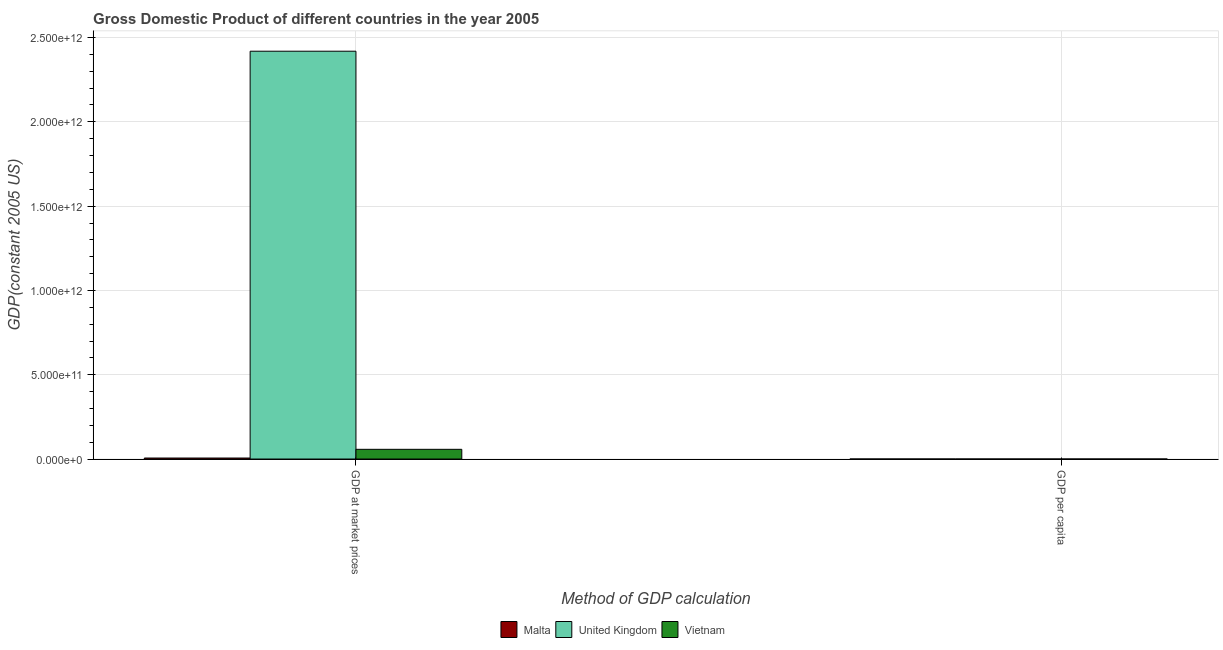Are the number of bars on each tick of the X-axis equal?
Provide a succinct answer. Yes. How many bars are there on the 2nd tick from the left?
Your response must be concise. 3. What is the label of the 1st group of bars from the left?
Ensure brevity in your answer.  GDP at market prices. What is the gdp per capita in Malta?
Your answer should be very brief. 1.48e+04. Across all countries, what is the maximum gdp per capita?
Make the answer very short. 4.00e+04. Across all countries, what is the minimum gdp at market prices?
Ensure brevity in your answer.  5.99e+09. In which country was the gdp per capita maximum?
Keep it short and to the point. United Kingdom. In which country was the gdp per capita minimum?
Offer a terse response. Vietnam. What is the total gdp per capita in the graph?
Provide a succinct answer. 5.56e+04. What is the difference between the gdp at market prices in Malta and that in Vietnam?
Your response must be concise. -5.16e+1. What is the difference between the gdp per capita in Vietnam and the gdp at market prices in Malta?
Ensure brevity in your answer.  -5.99e+09. What is the average gdp at market prices per country?
Provide a succinct answer. 8.28e+11. What is the difference between the gdp per capita and gdp at market prices in Malta?
Your answer should be compact. -5.99e+09. What is the ratio of the gdp at market prices in United Kingdom to that in Malta?
Ensure brevity in your answer.  403.79. What does the 1st bar from the left in GDP per capita represents?
Offer a terse response. Malta. What does the 3rd bar from the right in GDP per capita represents?
Your answer should be very brief. Malta. How many countries are there in the graph?
Offer a terse response. 3. What is the difference between two consecutive major ticks on the Y-axis?
Provide a short and direct response. 5.00e+11. Does the graph contain any zero values?
Give a very brief answer. No. Where does the legend appear in the graph?
Keep it short and to the point. Bottom center. How many legend labels are there?
Make the answer very short. 3. What is the title of the graph?
Provide a succinct answer. Gross Domestic Product of different countries in the year 2005. What is the label or title of the X-axis?
Provide a short and direct response. Method of GDP calculation. What is the label or title of the Y-axis?
Ensure brevity in your answer.  GDP(constant 2005 US). What is the GDP(constant 2005 US) in Malta in GDP at market prices?
Ensure brevity in your answer.  5.99e+09. What is the GDP(constant 2005 US) in United Kingdom in GDP at market prices?
Ensure brevity in your answer.  2.42e+12. What is the GDP(constant 2005 US) in Vietnam in GDP at market prices?
Your answer should be very brief. 5.76e+1. What is the GDP(constant 2005 US) in Malta in GDP per capita?
Ensure brevity in your answer.  1.48e+04. What is the GDP(constant 2005 US) of United Kingdom in GDP per capita?
Your answer should be compact. 4.00e+04. What is the GDP(constant 2005 US) in Vietnam in GDP per capita?
Keep it short and to the point. 699.5. Across all Method of GDP calculation, what is the maximum GDP(constant 2005 US) in Malta?
Provide a succinct answer. 5.99e+09. Across all Method of GDP calculation, what is the maximum GDP(constant 2005 US) of United Kingdom?
Your answer should be compact. 2.42e+12. Across all Method of GDP calculation, what is the maximum GDP(constant 2005 US) of Vietnam?
Offer a very short reply. 5.76e+1. Across all Method of GDP calculation, what is the minimum GDP(constant 2005 US) of Malta?
Offer a very short reply. 1.48e+04. Across all Method of GDP calculation, what is the minimum GDP(constant 2005 US) of United Kingdom?
Ensure brevity in your answer.  4.00e+04. Across all Method of GDP calculation, what is the minimum GDP(constant 2005 US) of Vietnam?
Make the answer very short. 699.5. What is the total GDP(constant 2005 US) in Malta in the graph?
Provide a succinct answer. 5.99e+09. What is the total GDP(constant 2005 US) in United Kingdom in the graph?
Keep it short and to the point. 2.42e+12. What is the total GDP(constant 2005 US) of Vietnam in the graph?
Give a very brief answer. 5.76e+1. What is the difference between the GDP(constant 2005 US) in Malta in GDP at market prices and that in GDP per capita?
Offer a very short reply. 5.99e+09. What is the difference between the GDP(constant 2005 US) in United Kingdom in GDP at market prices and that in GDP per capita?
Make the answer very short. 2.42e+12. What is the difference between the GDP(constant 2005 US) in Vietnam in GDP at market prices and that in GDP per capita?
Make the answer very short. 5.76e+1. What is the difference between the GDP(constant 2005 US) in Malta in GDP at market prices and the GDP(constant 2005 US) in United Kingdom in GDP per capita?
Offer a terse response. 5.99e+09. What is the difference between the GDP(constant 2005 US) of Malta in GDP at market prices and the GDP(constant 2005 US) of Vietnam in GDP per capita?
Give a very brief answer. 5.99e+09. What is the difference between the GDP(constant 2005 US) in United Kingdom in GDP at market prices and the GDP(constant 2005 US) in Vietnam in GDP per capita?
Offer a very short reply. 2.42e+12. What is the average GDP(constant 2005 US) in Malta per Method of GDP calculation?
Your answer should be compact. 3.00e+09. What is the average GDP(constant 2005 US) of United Kingdom per Method of GDP calculation?
Your answer should be very brief. 1.21e+12. What is the average GDP(constant 2005 US) in Vietnam per Method of GDP calculation?
Ensure brevity in your answer.  2.88e+1. What is the difference between the GDP(constant 2005 US) of Malta and GDP(constant 2005 US) of United Kingdom in GDP at market prices?
Offer a terse response. -2.41e+12. What is the difference between the GDP(constant 2005 US) in Malta and GDP(constant 2005 US) in Vietnam in GDP at market prices?
Offer a terse response. -5.16e+1. What is the difference between the GDP(constant 2005 US) in United Kingdom and GDP(constant 2005 US) in Vietnam in GDP at market prices?
Give a very brief answer. 2.36e+12. What is the difference between the GDP(constant 2005 US) of Malta and GDP(constant 2005 US) of United Kingdom in GDP per capita?
Give a very brief answer. -2.52e+04. What is the difference between the GDP(constant 2005 US) of Malta and GDP(constant 2005 US) of Vietnam in GDP per capita?
Offer a very short reply. 1.41e+04. What is the difference between the GDP(constant 2005 US) in United Kingdom and GDP(constant 2005 US) in Vietnam in GDP per capita?
Offer a terse response. 3.93e+04. What is the ratio of the GDP(constant 2005 US) in Malta in GDP at market prices to that in GDP per capita?
Keep it short and to the point. 4.04e+05. What is the ratio of the GDP(constant 2005 US) in United Kingdom in GDP at market prices to that in GDP per capita?
Make the answer very short. 6.04e+07. What is the ratio of the GDP(constant 2005 US) of Vietnam in GDP at market prices to that in GDP per capita?
Offer a very short reply. 8.24e+07. What is the difference between the highest and the second highest GDP(constant 2005 US) of Malta?
Give a very brief answer. 5.99e+09. What is the difference between the highest and the second highest GDP(constant 2005 US) in United Kingdom?
Your answer should be very brief. 2.42e+12. What is the difference between the highest and the second highest GDP(constant 2005 US) in Vietnam?
Your answer should be compact. 5.76e+1. What is the difference between the highest and the lowest GDP(constant 2005 US) of Malta?
Offer a terse response. 5.99e+09. What is the difference between the highest and the lowest GDP(constant 2005 US) in United Kingdom?
Your response must be concise. 2.42e+12. What is the difference between the highest and the lowest GDP(constant 2005 US) in Vietnam?
Your response must be concise. 5.76e+1. 